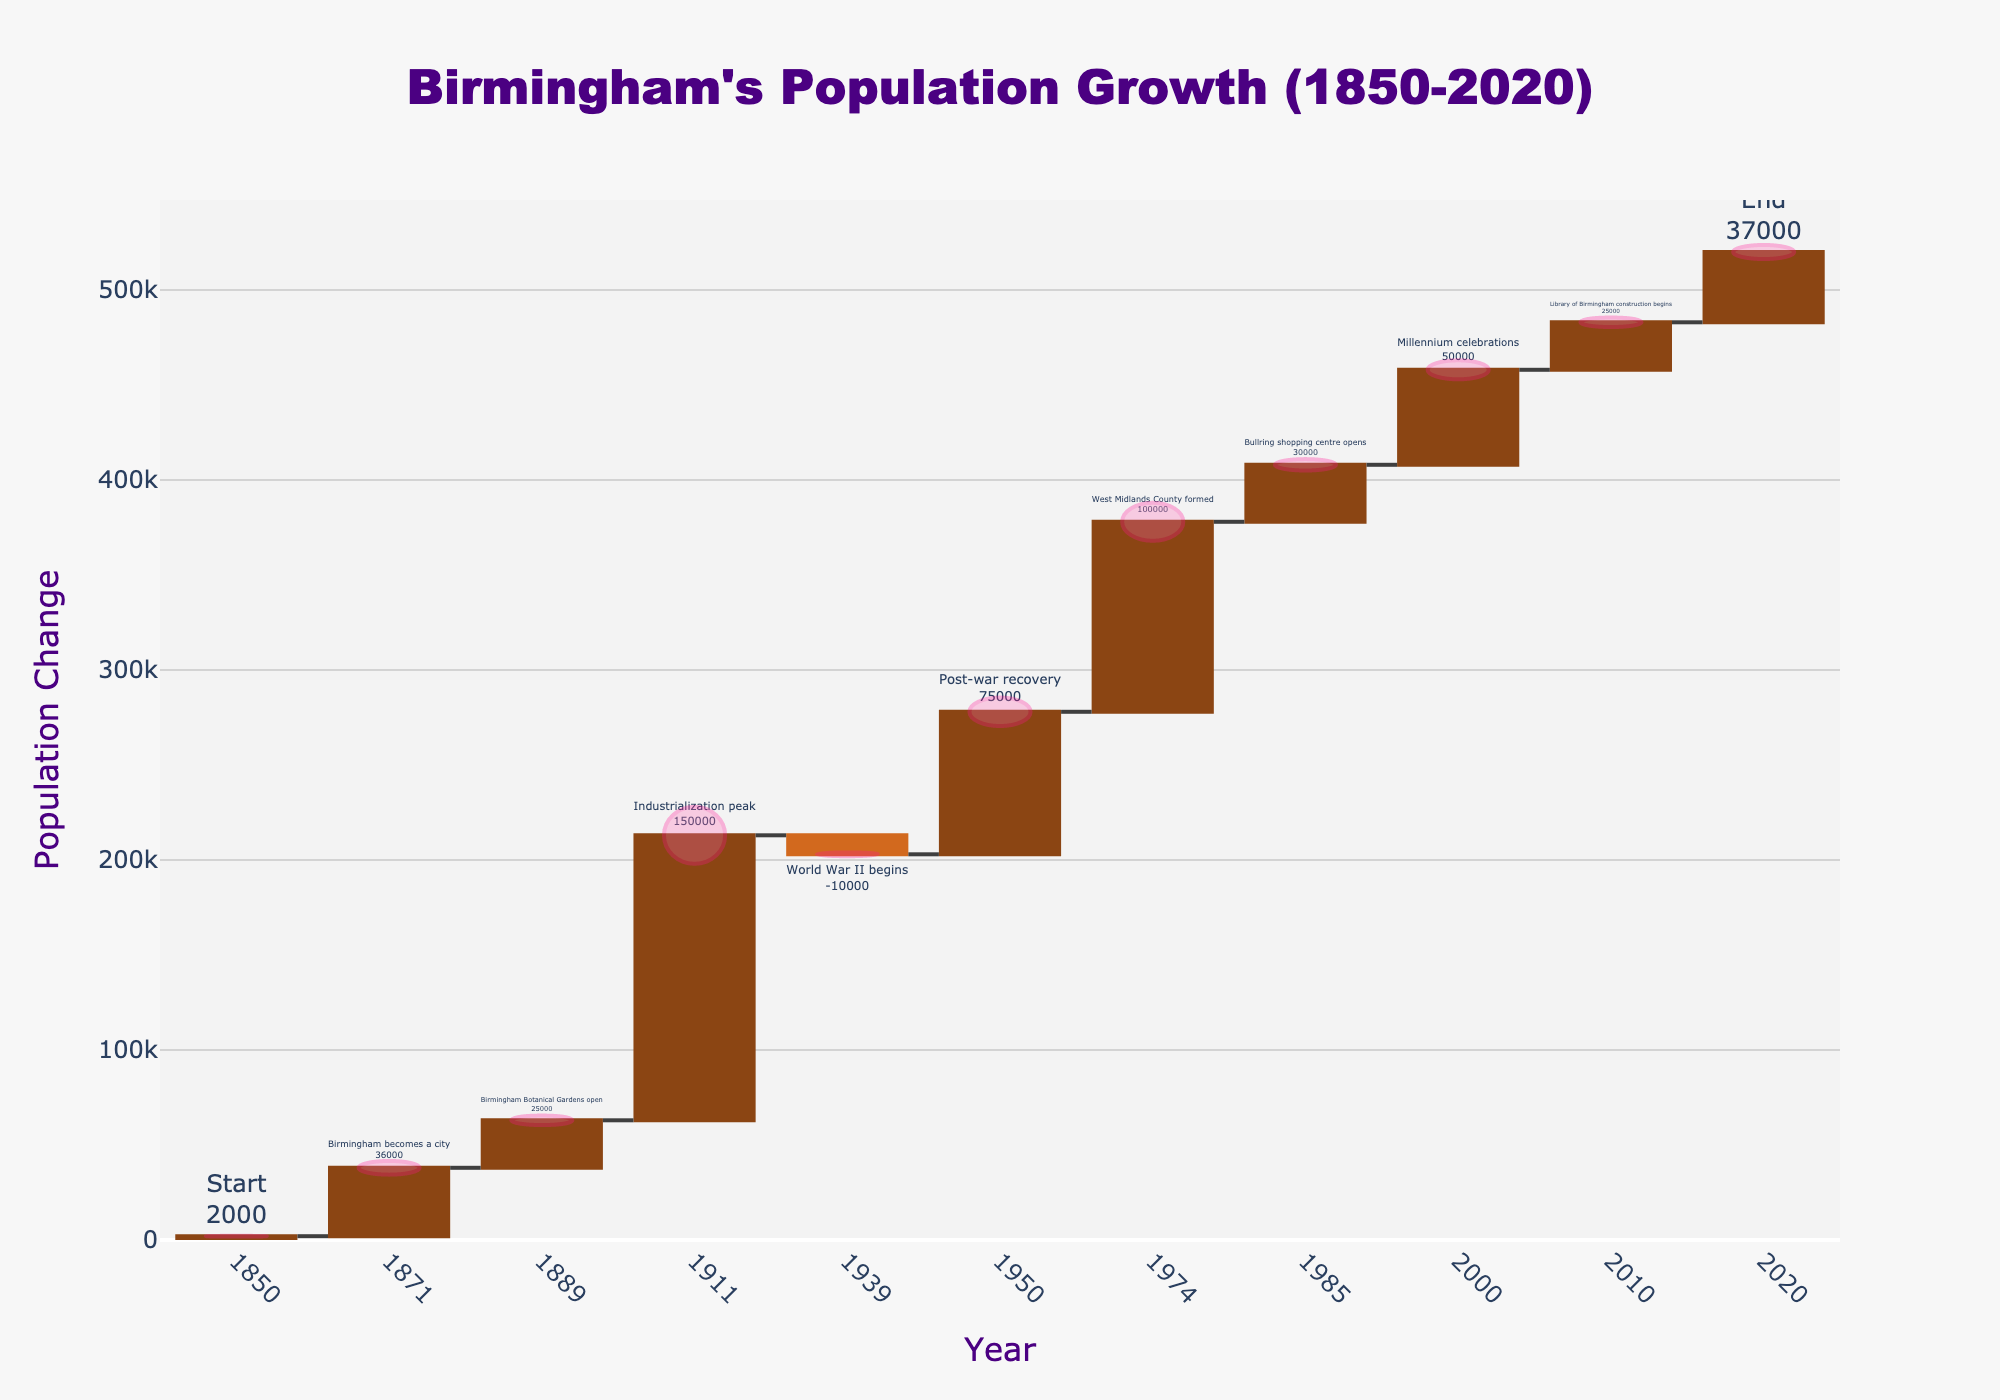What's the title of the figure? The title of the figure is displayed at the top and reads "Birmingham's Population Growth (1850-2020)"
Answer: Birmingham's Population Growth (1850-2020) What does the y-axis represent? The y-axis represents population change, which indicates the increase or decrease in Birmingham's population over time. The y-axis title "Population Change" clarifies this.
Answer: Population Change How many events are shown in the figure? Count the number of bars in the waterfall chart, each representing an event. There are 11 bars in total from 1850 to 2020.
Answer: 11 Which event caused the highest population increase? Look for the tallest bar in the positive direction. The event "Industrialization peak" in 1911 caused the highest population increase of +150,000.
Answer: Industrialization peak Which event caused a population decrease? Identify bars that go downward to determine negative population changes. The event "World War II begins" in 1939 caused a population decrease of -10,000.
Answer: World War II begins What is the population change in the year 2000? Refer to the bar for the year 2000, labeled "Millennium celebrations," which indicates a population change of +50,000.
Answer: +50,000 Was the overall population change positive or negative from 1850 to 2020? Summing all the population changes: 2000 + 36000 + 25000 + 150000 - 10000 + 75000 + 100000 + 30000 + 50000 + 25000 + 37000 = 510,000, which is positive.
Answer: Positive How did World War II affect Birmingham's population? Refer to the bar for 1939 labeled "World War II begins," showing a population decrease of -10,000.
Answer: Decrease of -10,000 Compare the population changes due to "Birmingham becomes a city" and "Bullring shopping centre opens". Which event had a larger impact? The "Birmingham becomes a city" event caused a change of +36,000, whereas the "Bullring shopping centre opens" caused a change of +30,000. Comparing these, "Birmingham becomes a city" had a larger impact.
Answer: Birmingham becomes a city What was the cumulative population change by 1950? Cumulative population by 1950 is the sum of changes in 1850, 1871, 1889, 1911, 1939: 2000 + 36000 + 25000 + 150000 - 10000 = 203,000.
Answer: +203,000 